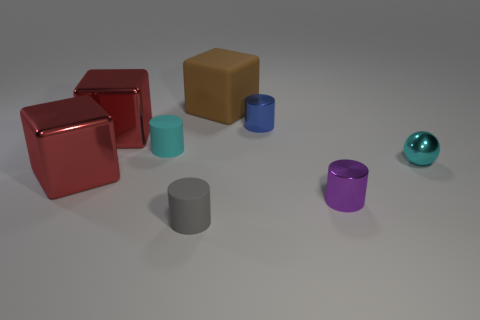Can you tell me the colors of the objects from left to right? From left to right, the objects are colored red, tan, light blue, blue, gray, purple, and teal. 